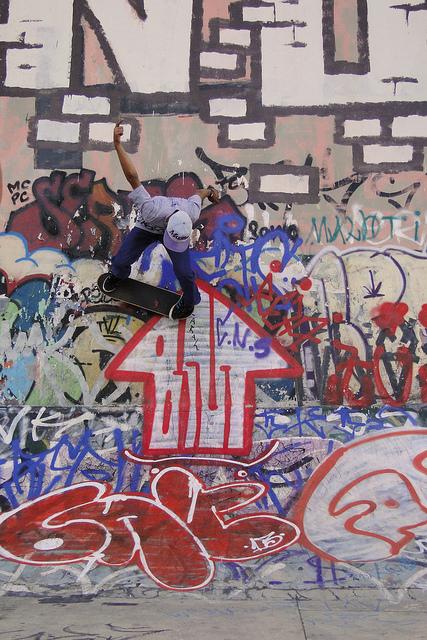What is on graffiti?
Answer briefly. Skateboarder. Is this graffiti excessive?
Quick response, please. Yes. What direction is the arrow pointing?
Answer briefly. Up. What is the boy riding on?
Answer briefly. Skateboard. 